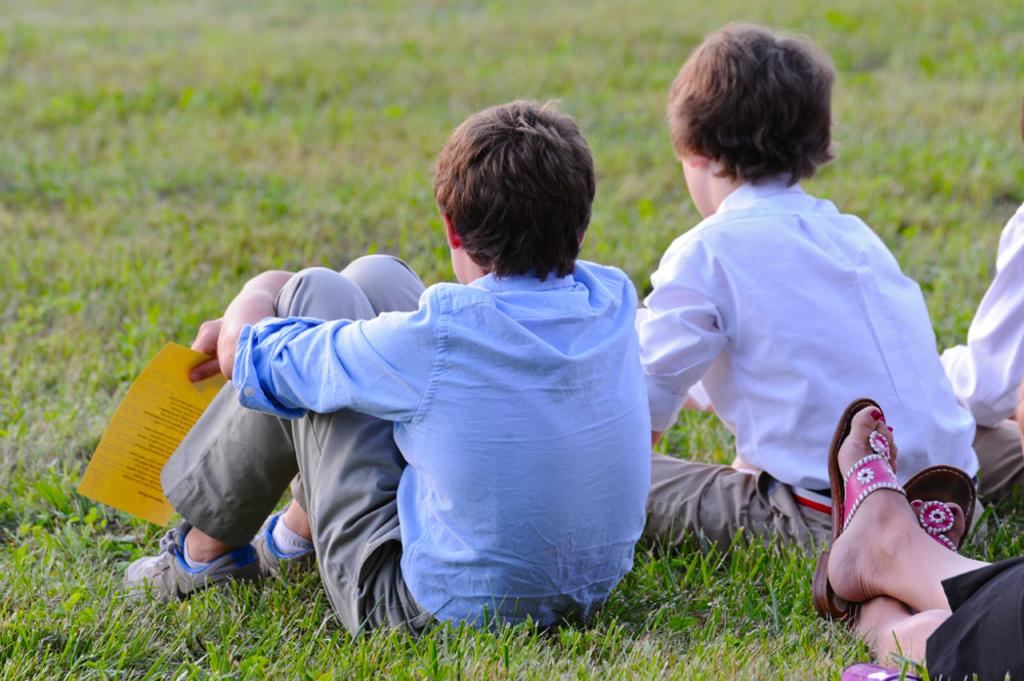What are the persons in the image doing? The persons in the image are sitting on the grass in the center of the image. What type of vegetation is visible in the image? There is grass visible in the image. Where are the legs of the persons located in the image? The legs of the persons are in the bottom right corner of the image. What type of pizzas are being eaten by the persons in the image? There is no indication of pizzas being present or consumed in the image. What time of day is it in the image, considering the presence of the morning? The time of day is not specified in the image, and there is no mention of morning. 